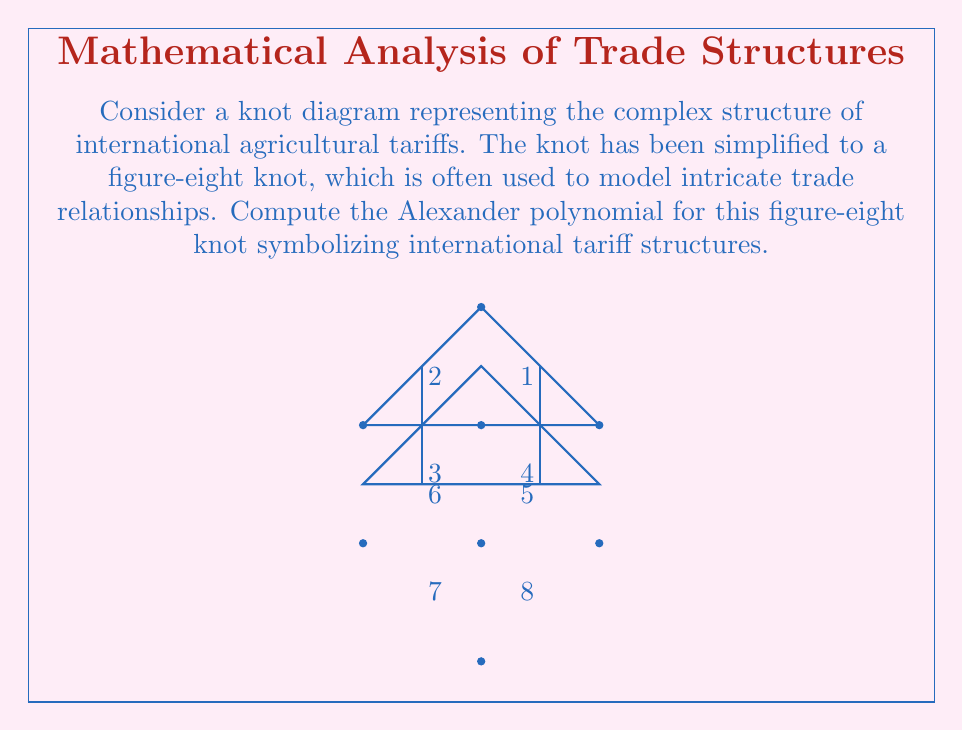Help me with this question. To compute the Alexander polynomial for the figure-eight knot representing international tariff structures, we'll follow these steps:

1) First, we need to label the arcs and crossings of the knot diagram. We've already done this in the figure provided.

2) Now, we create the Alexander matrix. For a knot with n crossings, this will be an (n-1) x (n-1) matrix. The figure-eight knot has 4 crossings, so our matrix will be 3x3.

3) For each crossing, we write an equation:
   $t(x_\text{over}) - x_\text{over} = x_\text{right} - x_\text{left}$
   where $x_\text{over}$ is the arc going over at the crossing, and $x_\text{right}$ and $x_\text{left}$ are the arcs to the right and left of the under-crossing respectively.

4) From these equations, we fill in the Alexander matrix:

   $$\begin{pmatrix}
   1-t & 1 & -1 \\
   -1 & 1-t & 1 \\
   1 & -1 & 1-t
   \end{pmatrix}$$

5) The Alexander polynomial is the determinant of this matrix, divided by $(t-1)$:

   $$\Delta(t) = \frac{1}{t-1}\det\begin{pmatrix}
   1-t & 1 & -1 \\
   -1 & 1-t & 1 \\
   1 & -1 & 1-t
   \end{pmatrix}$$

6) Expanding the determinant:
   $\Delta(t) = \frac{1}{t-1}[(1-t)((1-t)(1-t)-1)+1((1-t)-1)+(-1)(-1-1+t)]$
              $= \frac{1}{t-1}[(1-t)(1-2t+t^2-1)+1-t-1+t-1-1+t]$
              $= \frac{1}{t-1}[1-3t+3t^2-t^3-1+t-1+t]$
              $= \frac{1}{t-1}[-1-t+3t^2-t^3]$
              $= -1-t+3t^2-t^3$

7) Typically, we normalize the Alexander polynomial so that the lowest degree term is positive and the polynomial is symmetric. To do this, we multiply by $-t$:

   $\Delta(t) = t^4 - 3t^3 + t^2 - t$

This polynomial symbolizes the complex interrelationships in international agricultural tariff structures, where each term could represent different layers or types of tariffs in the global trade system.
Answer: $\Delta(t) = t^4 - 3t^3 + t^2 - t$ 